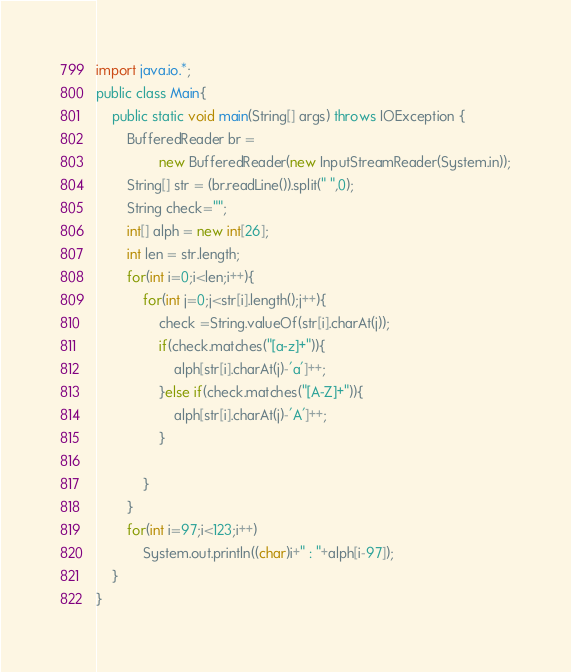<code> <loc_0><loc_0><loc_500><loc_500><_Java_>import java.io.*;
public class Main{
	public static void main(String[] args) throws IOException {
		BufferedReader br = 
				new BufferedReader(new InputStreamReader(System.in));
		String[] str = (br.readLine()).split(" ",0); 
		String check="";
		int[] alph = new int[26];
		int len = str.length;
		for(int i=0;i<len;i++){
			for(int j=0;j<str[i].length();j++){
				check =String.valueOf(str[i].charAt(j));
				if(check.matches("[a-z]+")){
					alph[str[i].charAt(j)-'a']++;
				}else if(check.matches("[A-Z]+")){
					alph[str[i].charAt(j)-'A']++;
				}
				
			}
		}
		for(int i=97;i<123;i++)
			System.out.println((char)i+" : "+alph[i-97]);
	}
}</code> 